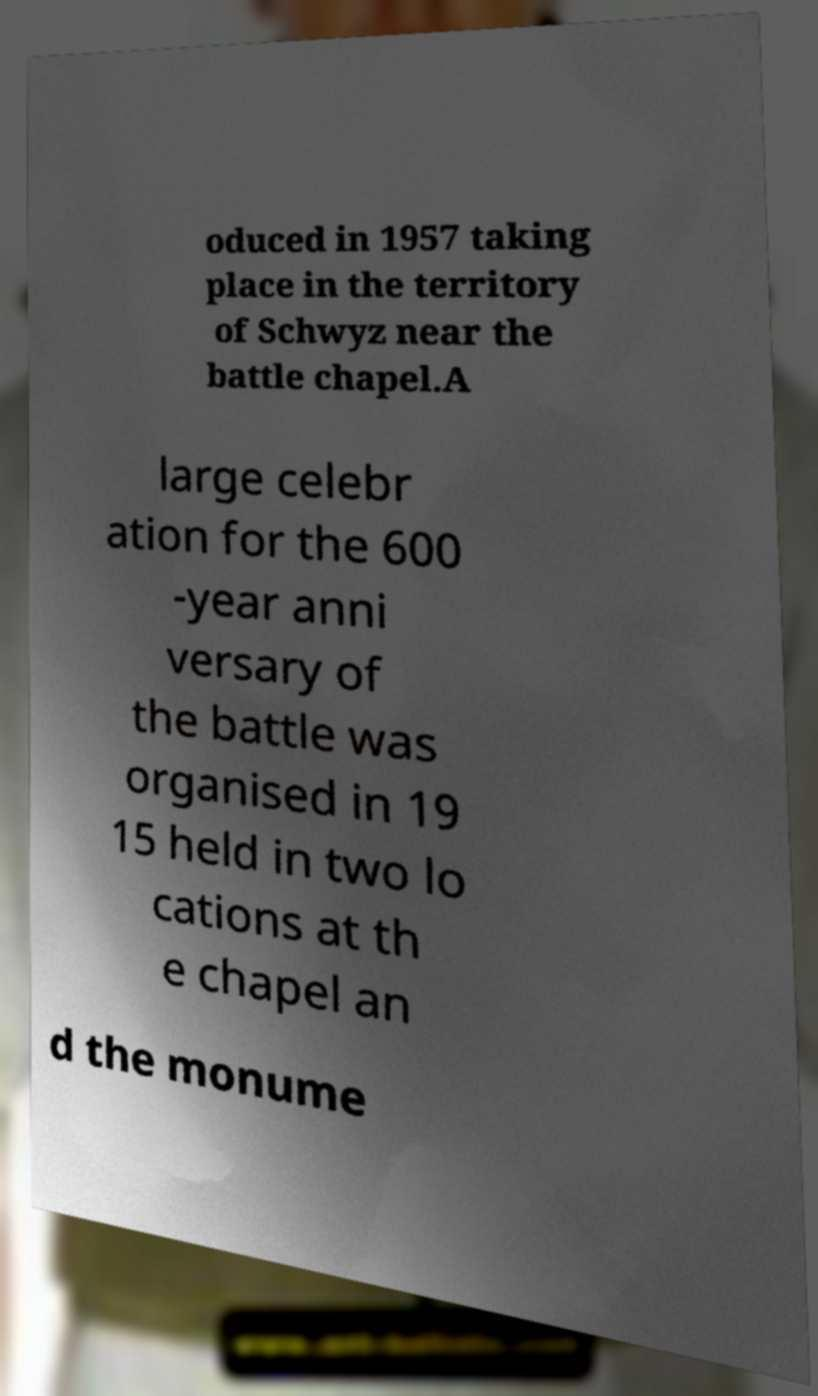Please read and relay the text visible in this image. What does it say? oduced in 1957 taking place in the territory of Schwyz near the battle chapel.A large celebr ation for the 600 -year anni versary of the battle was organised in 19 15 held in two lo cations at th e chapel an d the monume 